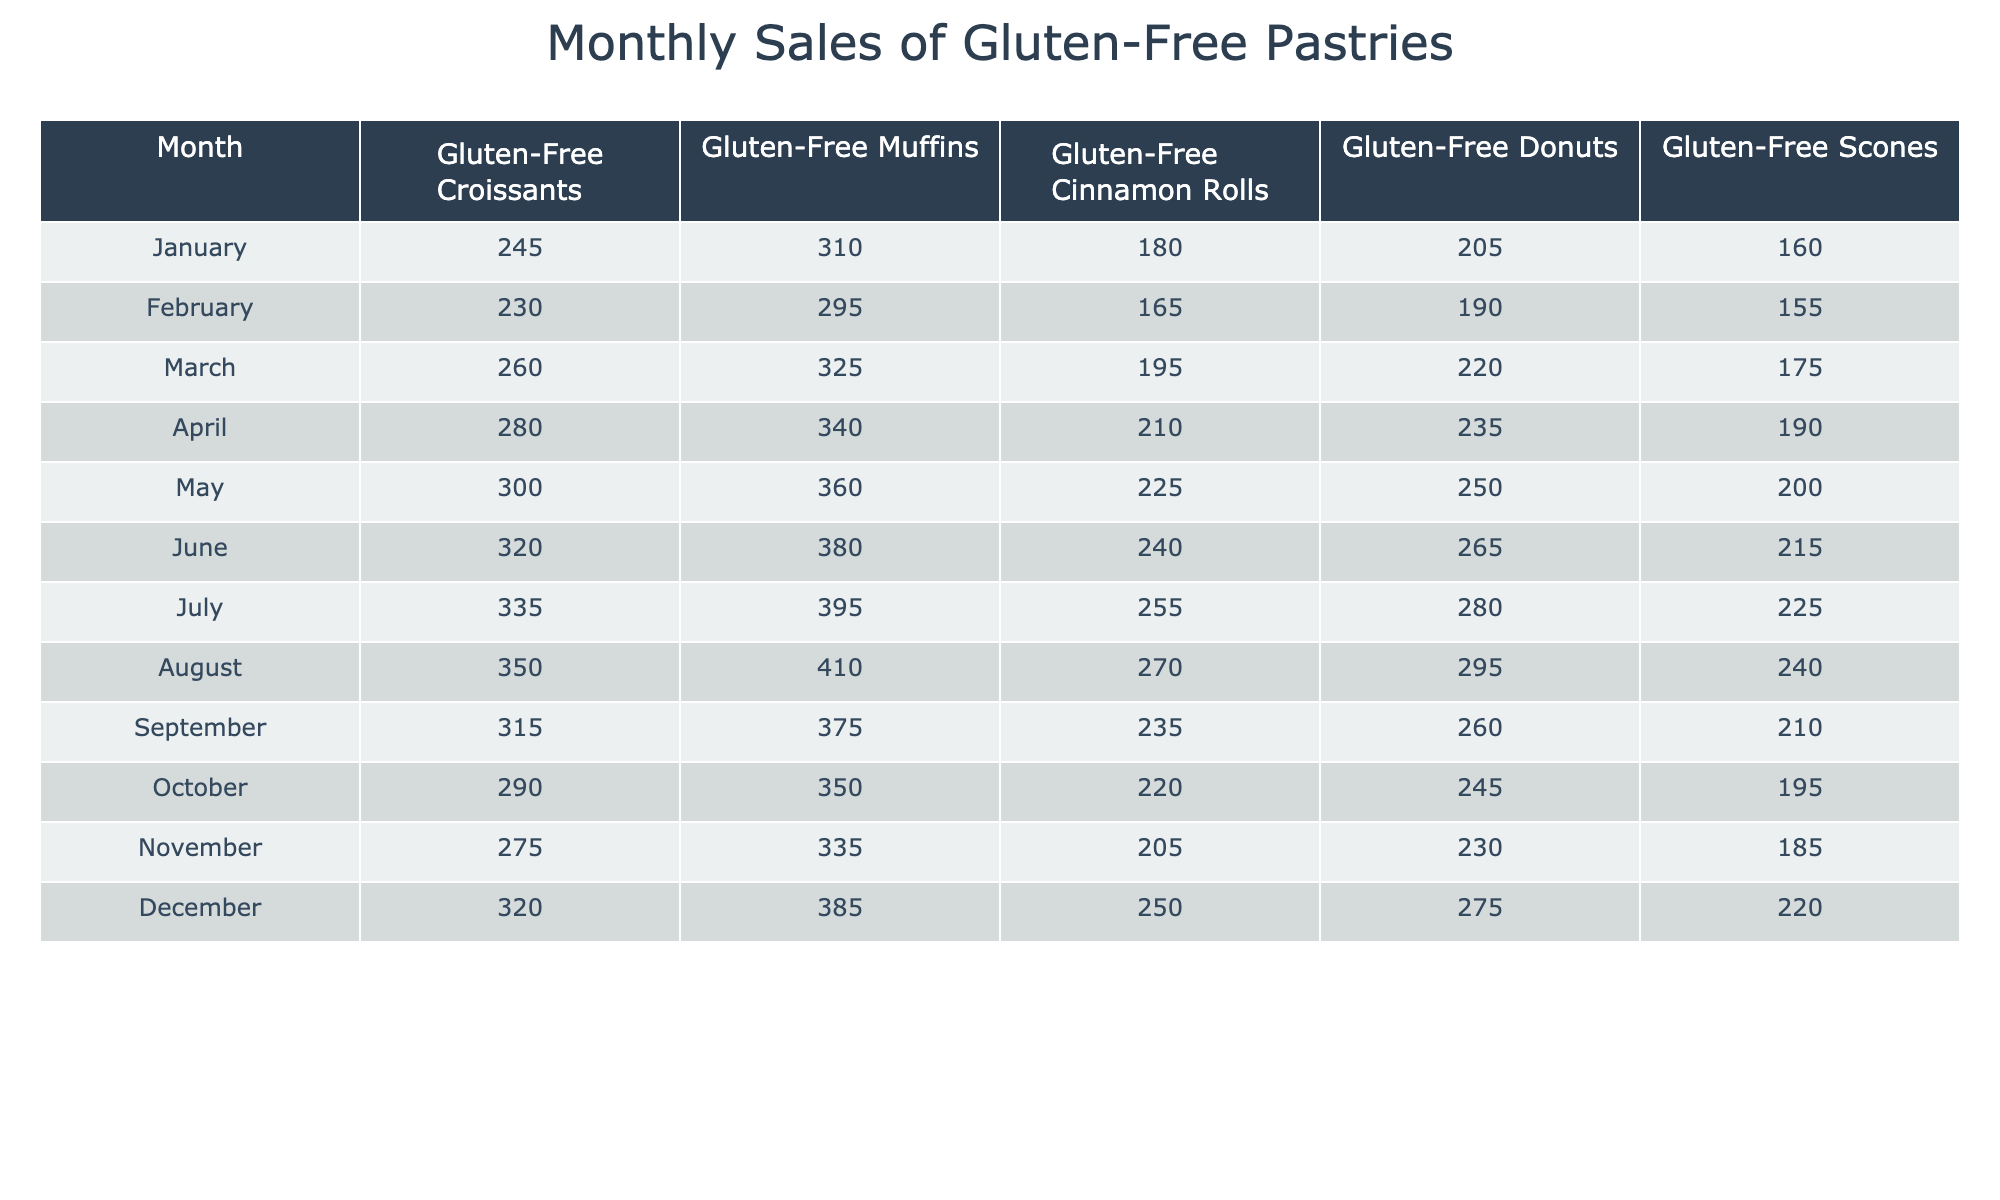What was the highest monthly sales of gluten-free croissants? Looking at the gluten-free croissants column, the highest value is 350 in August.
Answer: 350 Which month had the lowest sales of gluten-free muffins? The gluten-free muffins column shows the lowest value of 295 in February.
Answer: 295 What is the average monthly sales of gluten-free cinnamon rolls? The values for gluten-free cinnamon rolls are (180 + 165 + 195 + 210 + 225 + 240 + 255 + 270 + 235 + 220 + 205 + 250) = 2,775. There are 12 months, so the average is 2,775 / 12 ≈ 231.25.
Answer: 231.25 Did the sales of gluten-free donuts increase every month from January to July? Comparing the values from January (205) to July (280), the sales consistently increased each month: 205 < 220 < 235 < 250 < 265 < 280. Therefore, it is true that the sales increased every month.
Answer: Yes What is the total sales of gluten-free scones for the first half of the year? The sales for gluten-free scones from January to June are: 160 + 155 + 175 + 190 + 200 + 215 = 1,095.
Answer: 1,095 Which month had the highest combined sales of all gluten-free pastries? Adding the sales for all pastries in each month, December has the highest total: 320 + 385 + 250 + 275 + 220 = 1,450, which is higher than any other month.
Answer: December What was the difference in sales of gluten-free donuts between August and October? In August, sales for gluten-free donuts were 295 and in October, they were 245. The difference is 295 - 245 = 50.
Answer: 50 Which pastry had the most consistent sales throughout the year based on the values provided? By examining the values, gluten-free muffins had a relatively smaller range of sales (310 to 410) compared to the others, indicating more consistency.
Answer: Gluten-Free Muffins What was the overall trend in sales for gluten-free pastries from January to December? By observing the data, sales generally increased during the first half of the year but showed signs of decline in the later months, indicating an overall fluctuation.
Answer: Fluctuating trend What was the total sales for each pastry type across all months? The total sales can be computed for each pastry type: Croissants (3,845), Muffins (3,950), Cinnamon Rolls (2,775), Donuts (3,075), Scones (2,370).
Answer: Croissants: 3,845, Muffins: 3,950, Cinnamon Rolls: 2,775, Donuts: 3,075, Scones: 2,370 